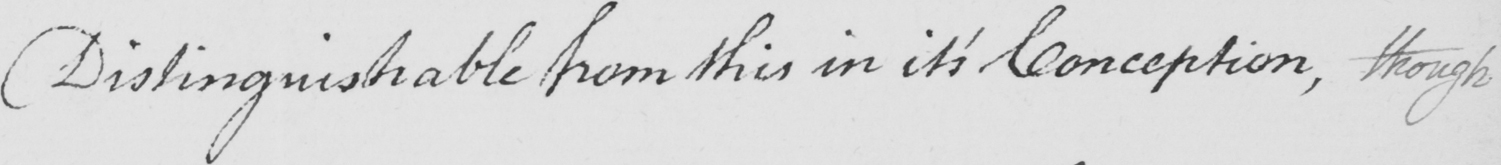Transcribe the text shown in this historical manuscript line. Distinguishable from this in it ' s Conception , though 